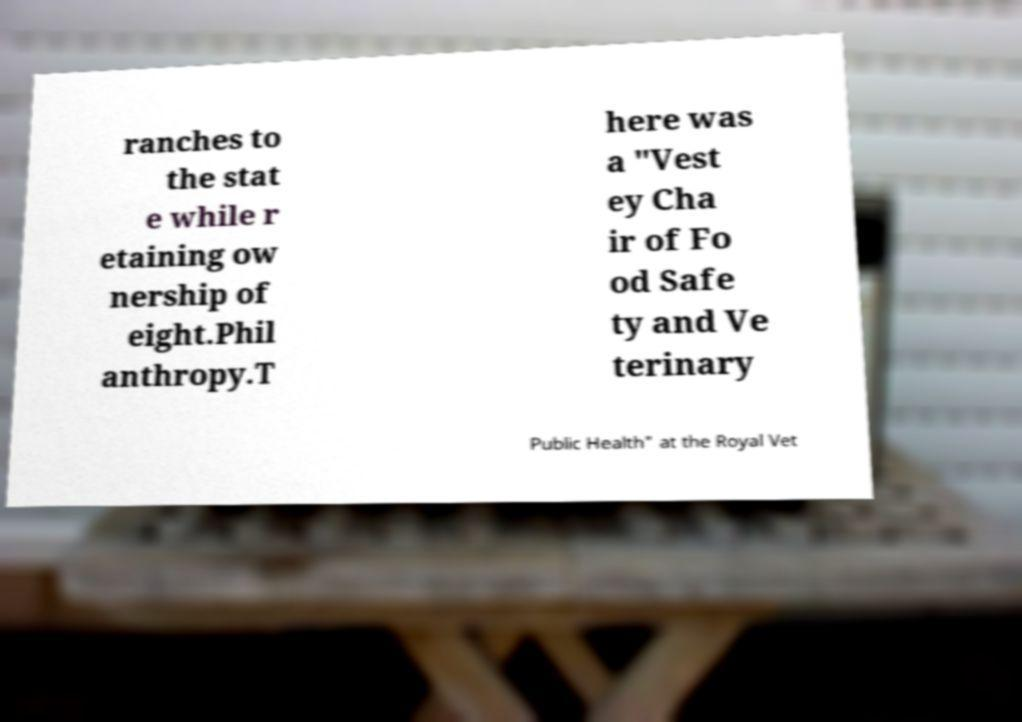Please identify and transcribe the text found in this image. ranches to the stat e while r etaining ow nership of eight.Phil anthropy.T here was a "Vest ey Cha ir of Fo od Safe ty and Ve terinary Public Health" at the Royal Vet 